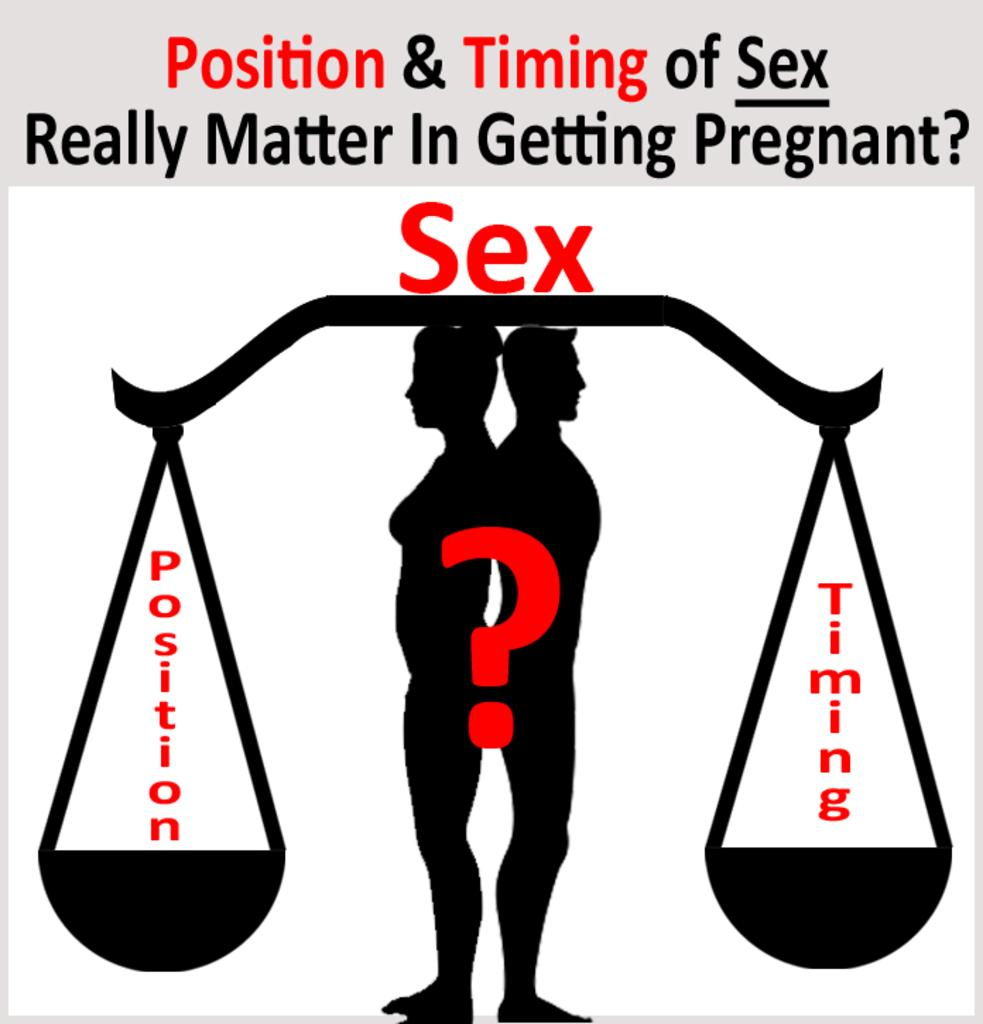<image>
Summarize the visual content of the image. An infographic for discussing the position and timing of getting pregnant during sex. 